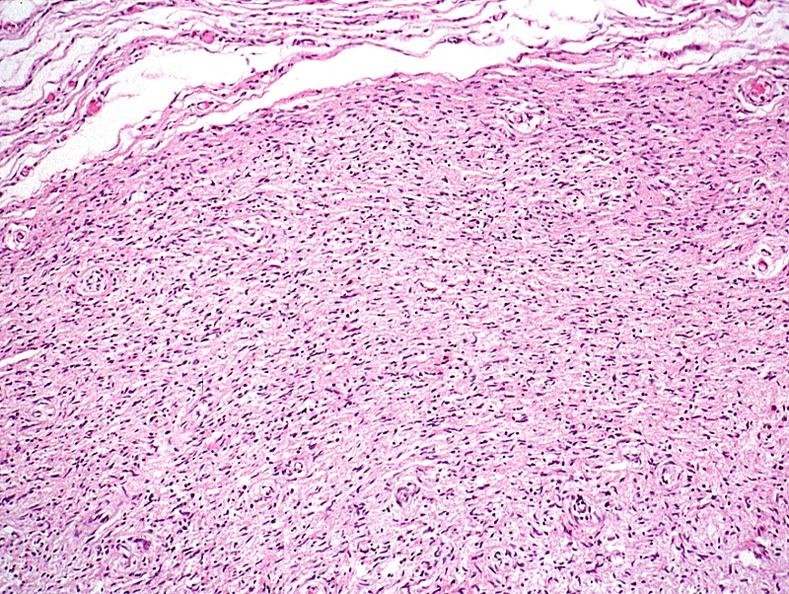does small intestine show skin, neurofibromatosis?
Answer the question using a single word or phrase. No 